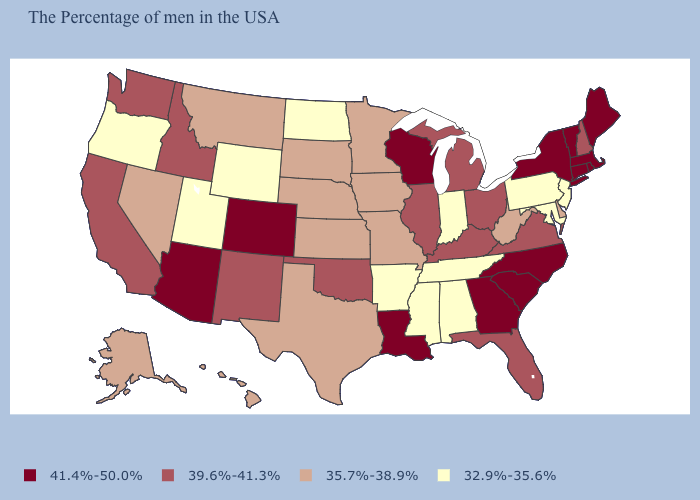Is the legend a continuous bar?
Short answer required. No. What is the value of Maryland?
Short answer required. 32.9%-35.6%. What is the lowest value in the USA?
Keep it brief. 32.9%-35.6%. How many symbols are there in the legend?
Quick response, please. 4. Name the states that have a value in the range 32.9%-35.6%?
Write a very short answer. New Jersey, Maryland, Pennsylvania, Indiana, Alabama, Tennessee, Mississippi, Arkansas, North Dakota, Wyoming, Utah, Oregon. Name the states that have a value in the range 35.7%-38.9%?
Give a very brief answer. Delaware, West Virginia, Missouri, Minnesota, Iowa, Kansas, Nebraska, Texas, South Dakota, Montana, Nevada, Alaska, Hawaii. What is the value of Kentucky?
Give a very brief answer. 39.6%-41.3%. Among the states that border Ohio , does Indiana have the lowest value?
Give a very brief answer. Yes. What is the value of New York?
Short answer required. 41.4%-50.0%. What is the value of Iowa?
Quick response, please. 35.7%-38.9%. What is the highest value in the USA?
Concise answer only. 41.4%-50.0%. How many symbols are there in the legend?
Be succinct. 4. 